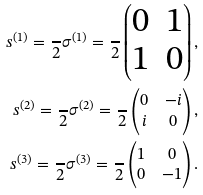<formula> <loc_0><loc_0><loc_500><loc_500>s ^ { ( 1 ) } = \frac { } { 2 } \sigma ^ { ( 1 ) } = \frac { } { 2 } \begin{pmatrix} 0 & 1 \\ 1 & 0 \end{pmatrix} , \\ s ^ { ( 2 ) } = \frac { } { 2 } \sigma ^ { ( 2 ) } = \frac { } { 2 } \begin{pmatrix} 0 & - i \\ i & 0 \end{pmatrix} , \\ s ^ { ( 3 ) } = \frac { } { 2 } \sigma ^ { ( 3 ) } = \frac { } { 2 } \begin{pmatrix} 1 & 0 \\ 0 & - 1 \end{pmatrix} .</formula> 